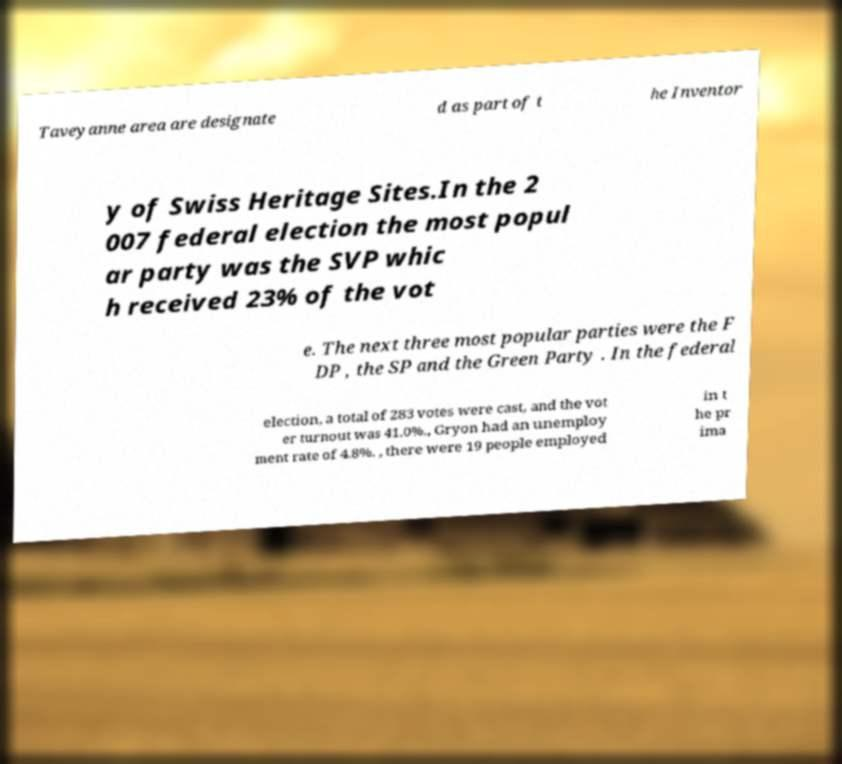Can you accurately transcribe the text from the provided image for me? Taveyanne area are designate d as part of t he Inventor y of Swiss Heritage Sites.In the 2 007 federal election the most popul ar party was the SVP whic h received 23% of the vot e. The next three most popular parties were the F DP , the SP and the Green Party . In the federal election, a total of 283 votes were cast, and the vot er turnout was 41.0%., Gryon had an unemploy ment rate of 4.8%. , there were 19 people employed in t he pr ima 